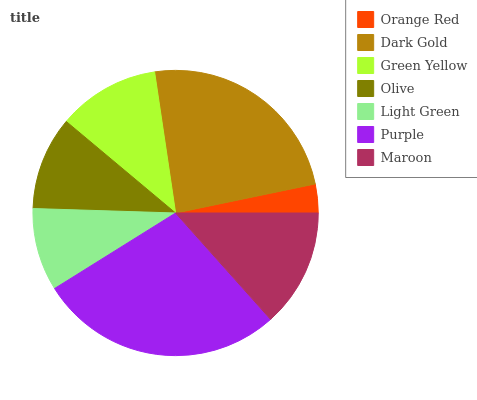Is Orange Red the minimum?
Answer yes or no. Yes. Is Purple the maximum?
Answer yes or no. Yes. Is Dark Gold the minimum?
Answer yes or no. No. Is Dark Gold the maximum?
Answer yes or no. No. Is Dark Gold greater than Orange Red?
Answer yes or no. Yes. Is Orange Red less than Dark Gold?
Answer yes or no. Yes. Is Orange Red greater than Dark Gold?
Answer yes or no. No. Is Dark Gold less than Orange Red?
Answer yes or no. No. Is Green Yellow the high median?
Answer yes or no. Yes. Is Green Yellow the low median?
Answer yes or no. Yes. Is Purple the high median?
Answer yes or no. No. Is Olive the low median?
Answer yes or no. No. 